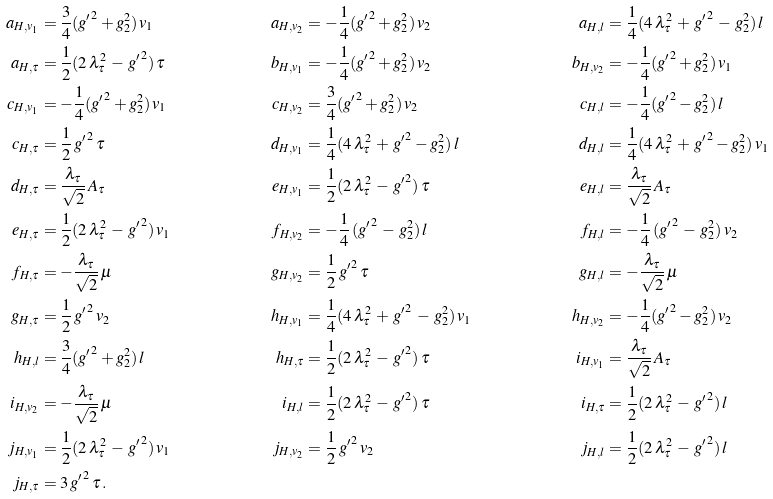Convert formula to latex. <formula><loc_0><loc_0><loc_500><loc_500>a _ { H , v _ { 1 } } & = \frac { 3 } { 4 } ( { g ^ { \prime } } ^ { 2 } + g _ { 2 } ^ { 2 } ) \, v _ { 1 } & a _ { H , v _ { 2 } } & = - \frac { 1 } { 4 } ( { g ^ { \prime } } ^ { 2 } + g _ { 2 } ^ { 2 } ) \, v _ { 2 } & a _ { H , l } & = \frac { 1 } { 4 } ( 4 \, \lambda _ { \tau } ^ { 2 } \, + \, { g ^ { \prime } } ^ { 2 } \, - \, g _ { 2 } ^ { 2 } ) \, l \\ a _ { H , \tau } & = \frac { 1 } { 2 } ( 2 \, \lambda _ { \tau } ^ { 2 } \, - \, { g ^ { \prime } } ^ { 2 } ) \, \tau & b _ { H , v _ { 1 } } & = - \frac { 1 } { 4 } ( { g ^ { \prime } } ^ { 2 } + g _ { 2 } ^ { 2 } ) \, v _ { 2 } & b _ { H , v _ { 2 } } & = - \frac { 1 } { 4 } ( { g ^ { \prime } } ^ { 2 } + g _ { 2 } ^ { 2 } ) \, v _ { 1 } \\ c _ { H , v _ { 1 } } & = - \frac { 1 } { 4 } ( { g ^ { \prime } } ^ { 2 } + g _ { 2 } ^ { 2 } ) \, v _ { 1 } & c _ { H , v _ { 2 } } & = \frac { 3 } { 4 } ( { g ^ { \prime } } ^ { 2 } + g _ { 2 } ^ { 2 } ) \, v _ { 2 } & c _ { H , l } & = - \frac { 1 } { 4 } ( { g ^ { \prime } } ^ { 2 } - g _ { 2 } ^ { 2 } ) \, l \\ c _ { H , \tau } & = \frac { 1 } { 2 } \, { g ^ { \prime } } ^ { 2 } \, \tau & d _ { H , v _ { 1 } } & = \frac { 1 } { 4 } ( 4 \, \lambda _ { \tau } ^ { 2 } \, + \, { g ^ { \prime } } ^ { 2 } - g _ { 2 } ^ { 2 } ) \, l & d _ { H , l } & = \frac { 1 } { 4 } ( 4 \, \lambda _ { \tau } ^ { 2 } \, + \, { g ^ { \prime } } ^ { 2 } - g _ { 2 } ^ { 2 } ) \, v _ { 1 } \\ d _ { H , \tau } & = \frac { \lambda _ { \tau } } { \sqrt { 2 } } \, A _ { \tau } & e _ { H , v _ { 1 } } & = \frac { 1 } { 2 } ( 2 \, \lambda _ { \tau } ^ { 2 } \, - \, { g ^ { \prime } } ^ { 2 } ) \, \tau & e _ { H , l } & = \frac { \lambda _ { \tau } } { \sqrt { 2 } } \, A _ { \tau } \\ e _ { H , \tau } & = \frac { 1 } { 2 } ( 2 \, \lambda _ { \tau } ^ { 2 } \, - \, { g ^ { \prime } } ^ { 2 } ) \, v _ { 1 } & f _ { H , v _ { 2 } } & = - \frac { 1 } { 4 } \, ( { g ^ { \prime } } ^ { 2 } \, - \, g _ { 2 } ^ { 2 } ) \, l & f _ { H , l } & = - \frac { 1 } { 4 } \, ( { g ^ { \prime } } ^ { 2 } \, - \, g _ { 2 } ^ { 2 } ) \, v _ { 2 } \\ f _ { H , \tau } & = - \frac { \lambda _ { \tau } } { \sqrt { 2 } } \, \mu & g _ { H , v _ { 2 } } & = \frac { 1 } { 2 } \, { g ^ { \prime } } ^ { 2 } \, \tau & g _ { H , l } & = - \frac { \lambda _ { \tau } } { \sqrt { 2 } } \, \mu \\ g _ { H , \tau } & = \frac { 1 } { 2 } \, { g ^ { \prime } } ^ { 2 } \, v _ { 2 } & h _ { H , v _ { 1 } } & = \frac { 1 } { 4 } ( 4 \, \lambda _ { \tau } ^ { 2 } \, + \, { g ^ { \prime } } ^ { 2 } \, - \, g _ { 2 } ^ { 2 } ) \, v _ { 1 } & h _ { H , v _ { 2 } } & = - \frac { 1 } { 4 } ( { g ^ { \prime } } ^ { 2 } - g _ { 2 } ^ { 2 } ) \, v _ { 2 } \\ h _ { H , l } & = \frac { 3 } { 4 } ( { g ^ { \prime } } ^ { 2 } + g _ { 2 } ^ { 2 } ) \, l & h _ { H , \tau } & = \frac { 1 } { 2 } ( 2 \, \lambda _ { \tau } ^ { 2 } \, - \, { g ^ { \prime } } ^ { 2 } ) \, \tau & i _ { H , v _ { 1 } } & = \frac { \lambda _ { \tau } } { \sqrt { 2 } } \, A _ { \tau } \\ i _ { H , v _ { 2 } } & = - \frac { \lambda _ { \tau } } { \sqrt { 2 } } \, \mu & i _ { H , l } & = \frac { 1 } { 2 } ( 2 \, \lambda _ { \tau } ^ { 2 } \, - \, { g ^ { \prime } } ^ { 2 } ) \, \tau & i _ { H , \tau } & = \frac { 1 } { 2 } ( 2 \, \lambda _ { \tau } ^ { 2 } \, - \, { g ^ { \prime } } ^ { 2 } ) \, l \\ j _ { H , v _ { 1 } } & = \frac { 1 } { 2 } ( 2 \, \lambda _ { \tau } ^ { 2 } \, - \, { g ^ { \prime } } ^ { 2 } ) \, v _ { 1 } & j _ { H , v _ { 2 } } & = \frac { 1 } { 2 } \, { g ^ { \prime } } ^ { 2 } \, v _ { 2 } & j _ { H , l } & = \frac { 1 } { 2 } ( 2 \, \lambda _ { \tau } ^ { 2 } \, - \, { g ^ { \prime } } ^ { 2 } ) \, l \\ j _ { H , \tau } & = 3 \, { g ^ { \prime } } ^ { 2 } \, \tau \, . & & & &</formula> 